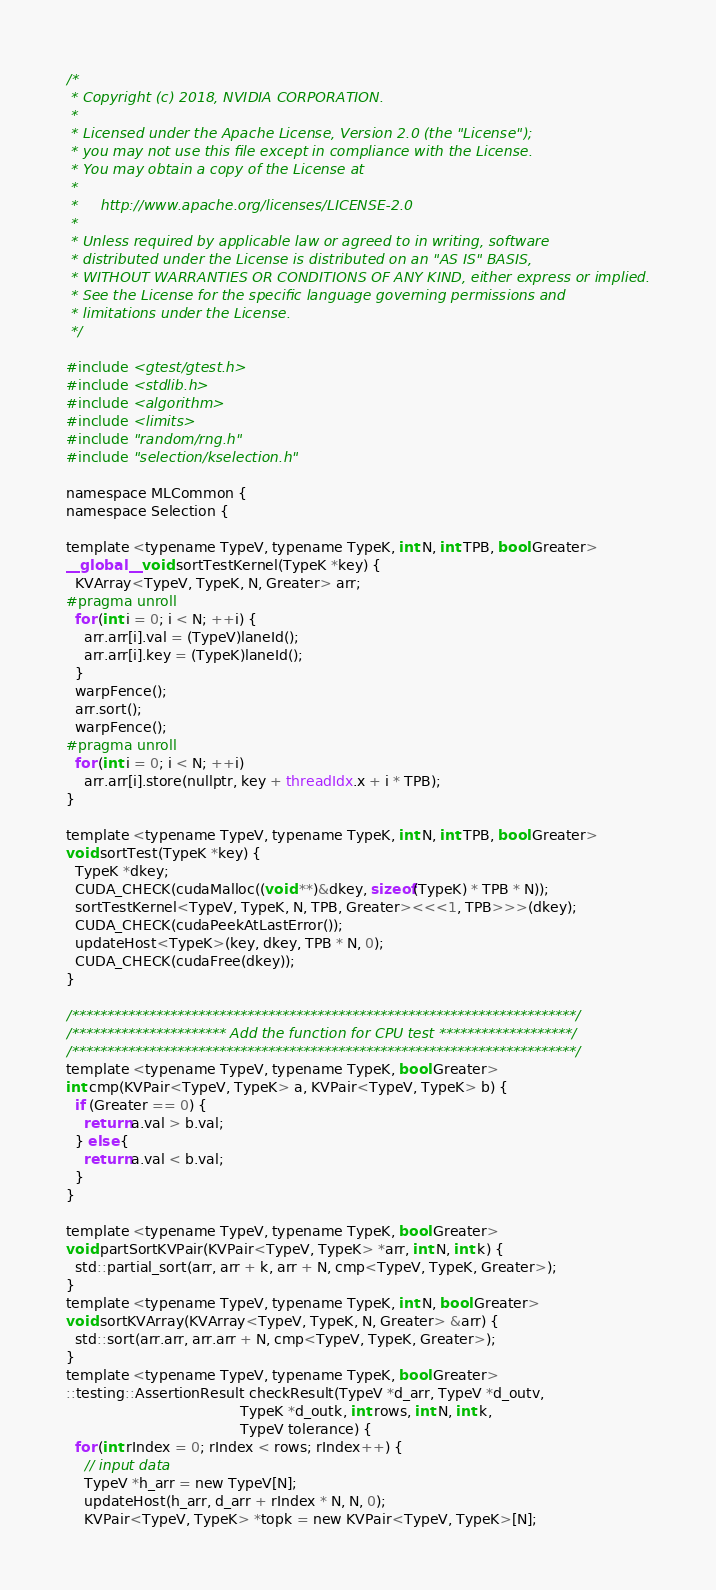Convert code to text. <code><loc_0><loc_0><loc_500><loc_500><_Cuda_>/*
 * Copyright (c) 2018, NVIDIA CORPORATION.
 *
 * Licensed under the Apache License, Version 2.0 (the "License");
 * you may not use this file except in compliance with the License.
 * You may obtain a copy of the License at
 *
 *     http://www.apache.org/licenses/LICENSE-2.0
 *
 * Unless required by applicable law or agreed to in writing, software
 * distributed under the License is distributed on an "AS IS" BASIS,
 * WITHOUT WARRANTIES OR CONDITIONS OF ANY KIND, either express or implied.
 * See the License for the specific language governing permissions and
 * limitations under the License.
 */

#include <gtest/gtest.h>
#include <stdlib.h>
#include <algorithm>
#include <limits>
#include "random/rng.h"
#include "selection/kselection.h"

namespace MLCommon {
namespace Selection {

template <typename TypeV, typename TypeK, int N, int TPB, bool Greater>
__global__ void sortTestKernel(TypeK *key) {
  KVArray<TypeV, TypeK, N, Greater> arr;
#pragma unroll
  for (int i = 0; i < N; ++i) {
    arr.arr[i].val = (TypeV)laneId();
    arr.arr[i].key = (TypeK)laneId();
  }
  warpFence();
  arr.sort();
  warpFence();
#pragma unroll
  for (int i = 0; i < N; ++i)
    arr.arr[i].store(nullptr, key + threadIdx.x + i * TPB);
}

template <typename TypeV, typename TypeK, int N, int TPB, bool Greater>
void sortTest(TypeK *key) {
  TypeK *dkey;
  CUDA_CHECK(cudaMalloc((void **)&dkey, sizeof(TypeK) * TPB * N));
  sortTestKernel<TypeV, TypeK, N, TPB, Greater><<<1, TPB>>>(dkey);
  CUDA_CHECK(cudaPeekAtLastError());
  updateHost<TypeK>(key, dkey, TPB * N, 0);
  CUDA_CHECK(cudaFree(dkey));
}

/************************************************************************/
/********************** Add the function for CPU test *******************/
/************************************************************************/
template <typename TypeV, typename TypeK, bool Greater>
int cmp(KVPair<TypeV, TypeK> a, KVPair<TypeV, TypeK> b) {
  if (Greater == 0) {
    return a.val > b.val;
  } else {
    return a.val < b.val;
  }
}

template <typename TypeV, typename TypeK, bool Greater>
void partSortKVPair(KVPair<TypeV, TypeK> *arr, int N, int k) {
  std::partial_sort(arr, arr + k, arr + N, cmp<TypeV, TypeK, Greater>);
}
template <typename TypeV, typename TypeK, int N, bool Greater>
void sortKVArray(KVArray<TypeV, TypeK, N, Greater> &arr) {
  std::sort(arr.arr, arr.arr + N, cmp<TypeV, TypeK, Greater>);
}
template <typename TypeV, typename TypeK, bool Greater>
::testing::AssertionResult checkResult(TypeV *d_arr, TypeV *d_outv,
                                       TypeK *d_outk, int rows, int N, int k,
                                       TypeV tolerance) {
  for (int rIndex = 0; rIndex < rows; rIndex++) {
    // input data
    TypeV *h_arr = new TypeV[N];
    updateHost(h_arr, d_arr + rIndex * N, N, 0);
    KVPair<TypeV, TypeK> *topk = new KVPair<TypeV, TypeK>[N];</code> 